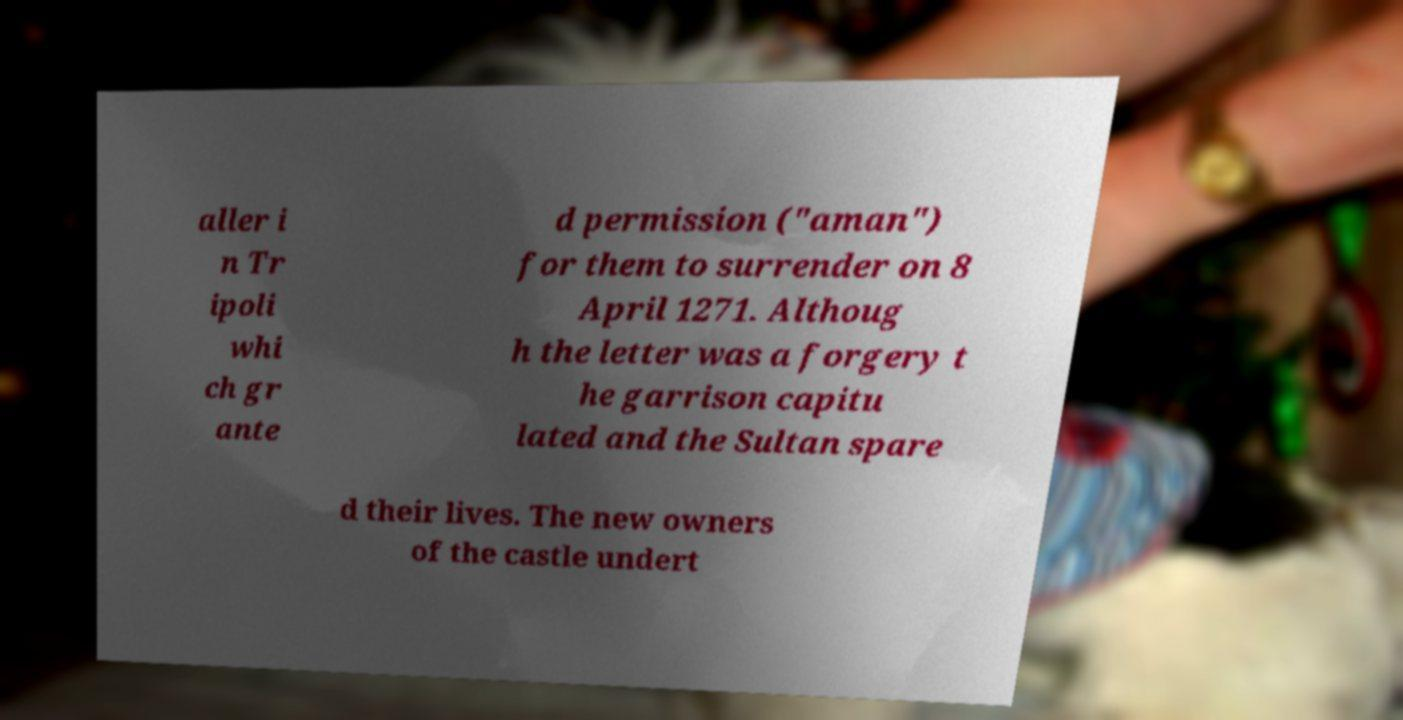There's text embedded in this image that I need extracted. Can you transcribe it verbatim? aller i n Tr ipoli whi ch gr ante d permission ("aman") for them to surrender on 8 April 1271. Althoug h the letter was a forgery t he garrison capitu lated and the Sultan spare d their lives. The new owners of the castle undert 